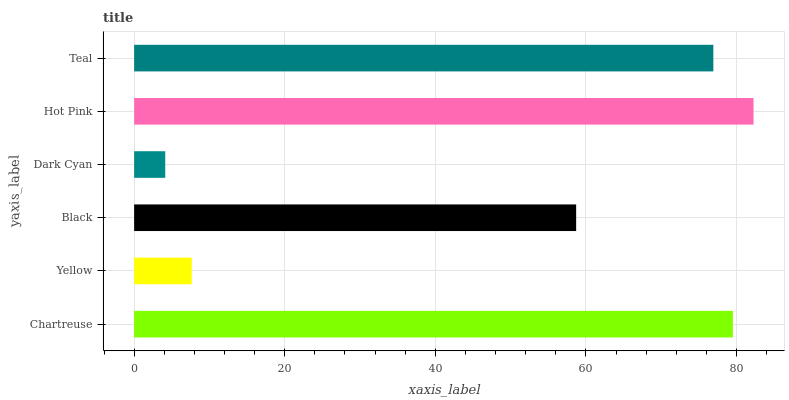Is Dark Cyan the minimum?
Answer yes or no. Yes. Is Hot Pink the maximum?
Answer yes or no. Yes. Is Yellow the minimum?
Answer yes or no. No. Is Yellow the maximum?
Answer yes or no. No. Is Chartreuse greater than Yellow?
Answer yes or no. Yes. Is Yellow less than Chartreuse?
Answer yes or no. Yes. Is Yellow greater than Chartreuse?
Answer yes or no. No. Is Chartreuse less than Yellow?
Answer yes or no. No. Is Teal the high median?
Answer yes or no. Yes. Is Black the low median?
Answer yes or no. Yes. Is Hot Pink the high median?
Answer yes or no. No. Is Yellow the low median?
Answer yes or no. No. 